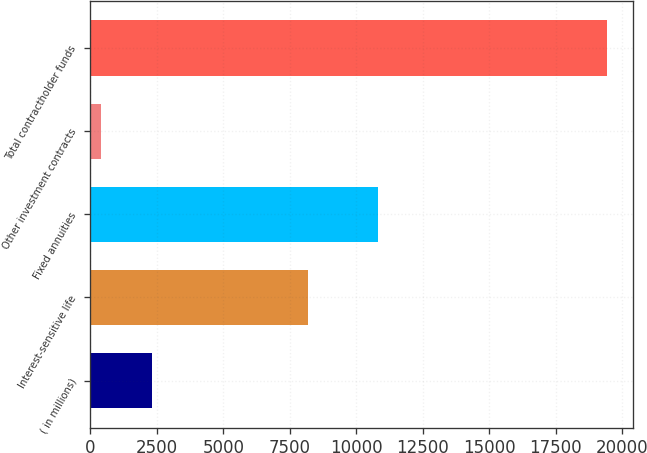Convert chart to OTSL. <chart><loc_0><loc_0><loc_500><loc_500><bar_chart><fcel>( in millions)<fcel>Interest-sensitive life<fcel>Fixed annuities<fcel>Other investment contracts<fcel>Total contractholder funds<nl><fcel>2317.8<fcel>8190<fcel>10828<fcel>416<fcel>19434<nl></chart> 